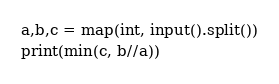Convert code to text. <code><loc_0><loc_0><loc_500><loc_500><_Python_>a,b,c = map(int, input().split())
print(min(c, b//a))</code> 